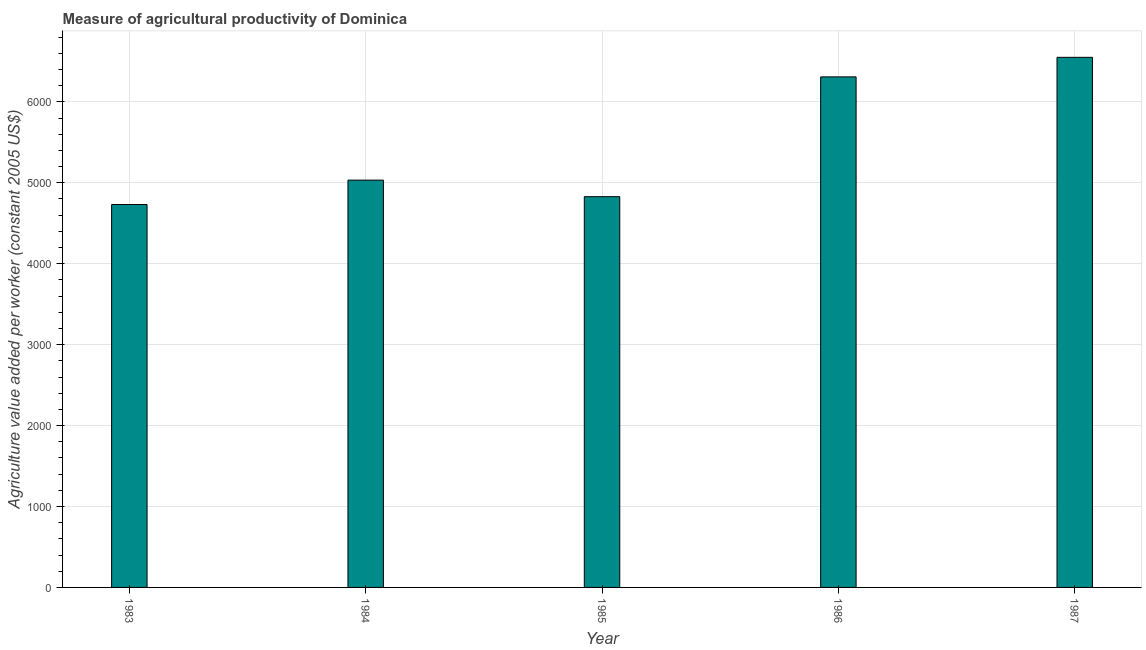What is the title of the graph?
Your response must be concise. Measure of agricultural productivity of Dominica. What is the label or title of the Y-axis?
Offer a very short reply. Agriculture value added per worker (constant 2005 US$). What is the agriculture value added per worker in 1983?
Your answer should be compact. 4731.35. Across all years, what is the maximum agriculture value added per worker?
Your response must be concise. 6550.31. Across all years, what is the minimum agriculture value added per worker?
Offer a very short reply. 4731.35. What is the sum of the agriculture value added per worker?
Offer a very short reply. 2.75e+04. What is the difference between the agriculture value added per worker in 1983 and 1987?
Provide a short and direct response. -1818.96. What is the average agriculture value added per worker per year?
Provide a succinct answer. 5490.3. What is the median agriculture value added per worker?
Give a very brief answer. 5032.82. In how many years, is the agriculture value added per worker greater than 4800 US$?
Your answer should be very brief. 4. What is the ratio of the agriculture value added per worker in 1983 to that in 1985?
Offer a very short reply. 0.98. Is the agriculture value added per worker in 1984 less than that in 1987?
Keep it short and to the point. Yes. Is the difference between the agriculture value added per worker in 1983 and 1984 greater than the difference between any two years?
Your response must be concise. No. What is the difference between the highest and the second highest agriculture value added per worker?
Ensure brevity in your answer.  241.67. Is the sum of the agriculture value added per worker in 1983 and 1985 greater than the maximum agriculture value added per worker across all years?
Your answer should be very brief. Yes. What is the difference between the highest and the lowest agriculture value added per worker?
Your answer should be very brief. 1818.96. How many bars are there?
Make the answer very short. 5. How many years are there in the graph?
Your response must be concise. 5. What is the Agriculture value added per worker (constant 2005 US$) of 1983?
Ensure brevity in your answer.  4731.35. What is the Agriculture value added per worker (constant 2005 US$) in 1984?
Your answer should be very brief. 5032.82. What is the Agriculture value added per worker (constant 2005 US$) of 1985?
Your answer should be very brief. 4828.38. What is the Agriculture value added per worker (constant 2005 US$) in 1986?
Ensure brevity in your answer.  6308.64. What is the Agriculture value added per worker (constant 2005 US$) in 1987?
Ensure brevity in your answer.  6550.31. What is the difference between the Agriculture value added per worker (constant 2005 US$) in 1983 and 1984?
Provide a succinct answer. -301.47. What is the difference between the Agriculture value added per worker (constant 2005 US$) in 1983 and 1985?
Your answer should be compact. -97.03. What is the difference between the Agriculture value added per worker (constant 2005 US$) in 1983 and 1986?
Make the answer very short. -1577.29. What is the difference between the Agriculture value added per worker (constant 2005 US$) in 1983 and 1987?
Give a very brief answer. -1818.96. What is the difference between the Agriculture value added per worker (constant 2005 US$) in 1984 and 1985?
Your response must be concise. 204.44. What is the difference between the Agriculture value added per worker (constant 2005 US$) in 1984 and 1986?
Offer a very short reply. -1275.82. What is the difference between the Agriculture value added per worker (constant 2005 US$) in 1984 and 1987?
Your answer should be very brief. -1517.49. What is the difference between the Agriculture value added per worker (constant 2005 US$) in 1985 and 1986?
Ensure brevity in your answer.  -1480.26. What is the difference between the Agriculture value added per worker (constant 2005 US$) in 1985 and 1987?
Keep it short and to the point. -1721.93. What is the difference between the Agriculture value added per worker (constant 2005 US$) in 1986 and 1987?
Offer a very short reply. -241.67. What is the ratio of the Agriculture value added per worker (constant 2005 US$) in 1983 to that in 1984?
Your answer should be compact. 0.94. What is the ratio of the Agriculture value added per worker (constant 2005 US$) in 1983 to that in 1985?
Provide a short and direct response. 0.98. What is the ratio of the Agriculture value added per worker (constant 2005 US$) in 1983 to that in 1986?
Give a very brief answer. 0.75. What is the ratio of the Agriculture value added per worker (constant 2005 US$) in 1983 to that in 1987?
Your answer should be compact. 0.72. What is the ratio of the Agriculture value added per worker (constant 2005 US$) in 1984 to that in 1985?
Your response must be concise. 1.04. What is the ratio of the Agriculture value added per worker (constant 2005 US$) in 1984 to that in 1986?
Provide a succinct answer. 0.8. What is the ratio of the Agriculture value added per worker (constant 2005 US$) in 1984 to that in 1987?
Give a very brief answer. 0.77. What is the ratio of the Agriculture value added per worker (constant 2005 US$) in 1985 to that in 1986?
Ensure brevity in your answer.  0.77. What is the ratio of the Agriculture value added per worker (constant 2005 US$) in 1985 to that in 1987?
Your answer should be compact. 0.74. 